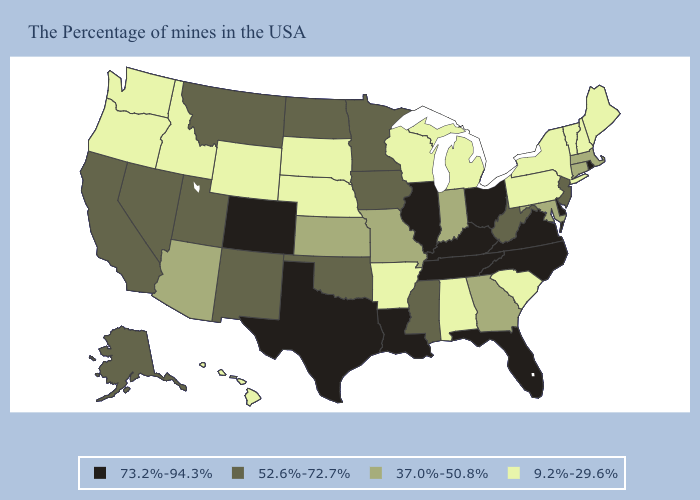Which states have the lowest value in the South?
Give a very brief answer. South Carolina, Alabama, Arkansas. Does South Carolina have the highest value in the USA?
Be succinct. No. Does Oregon have the lowest value in the USA?
Write a very short answer. Yes. Does the first symbol in the legend represent the smallest category?
Concise answer only. No. Name the states that have a value in the range 37.0%-50.8%?
Quick response, please. Massachusetts, Connecticut, Maryland, Georgia, Indiana, Missouri, Kansas, Arizona. What is the highest value in the MidWest ?
Give a very brief answer. 73.2%-94.3%. Which states have the lowest value in the USA?
Concise answer only. Maine, New Hampshire, Vermont, New York, Pennsylvania, South Carolina, Michigan, Alabama, Wisconsin, Arkansas, Nebraska, South Dakota, Wyoming, Idaho, Washington, Oregon, Hawaii. Among the states that border Virginia , does Maryland have the highest value?
Concise answer only. No. What is the highest value in states that border Washington?
Short answer required. 9.2%-29.6%. How many symbols are there in the legend?
Be succinct. 4. What is the value of Texas?
Concise answer only. 73.2%-94.3%. Name the states that have a value in the range 37.0%-50.8%?
Short answer required. Massachusetts, Connecticut, Maryland, Georgia, Indiana, Missouri, Kansas, Arizona. Among the states that border Oregon , does California have the lowest value?
Be succinct. No. What is the value of Oregon?
Concise answer only. 9.2%-29.6%. What is the value of Montana?
Quick response, please. 52.6%-72.7%. 